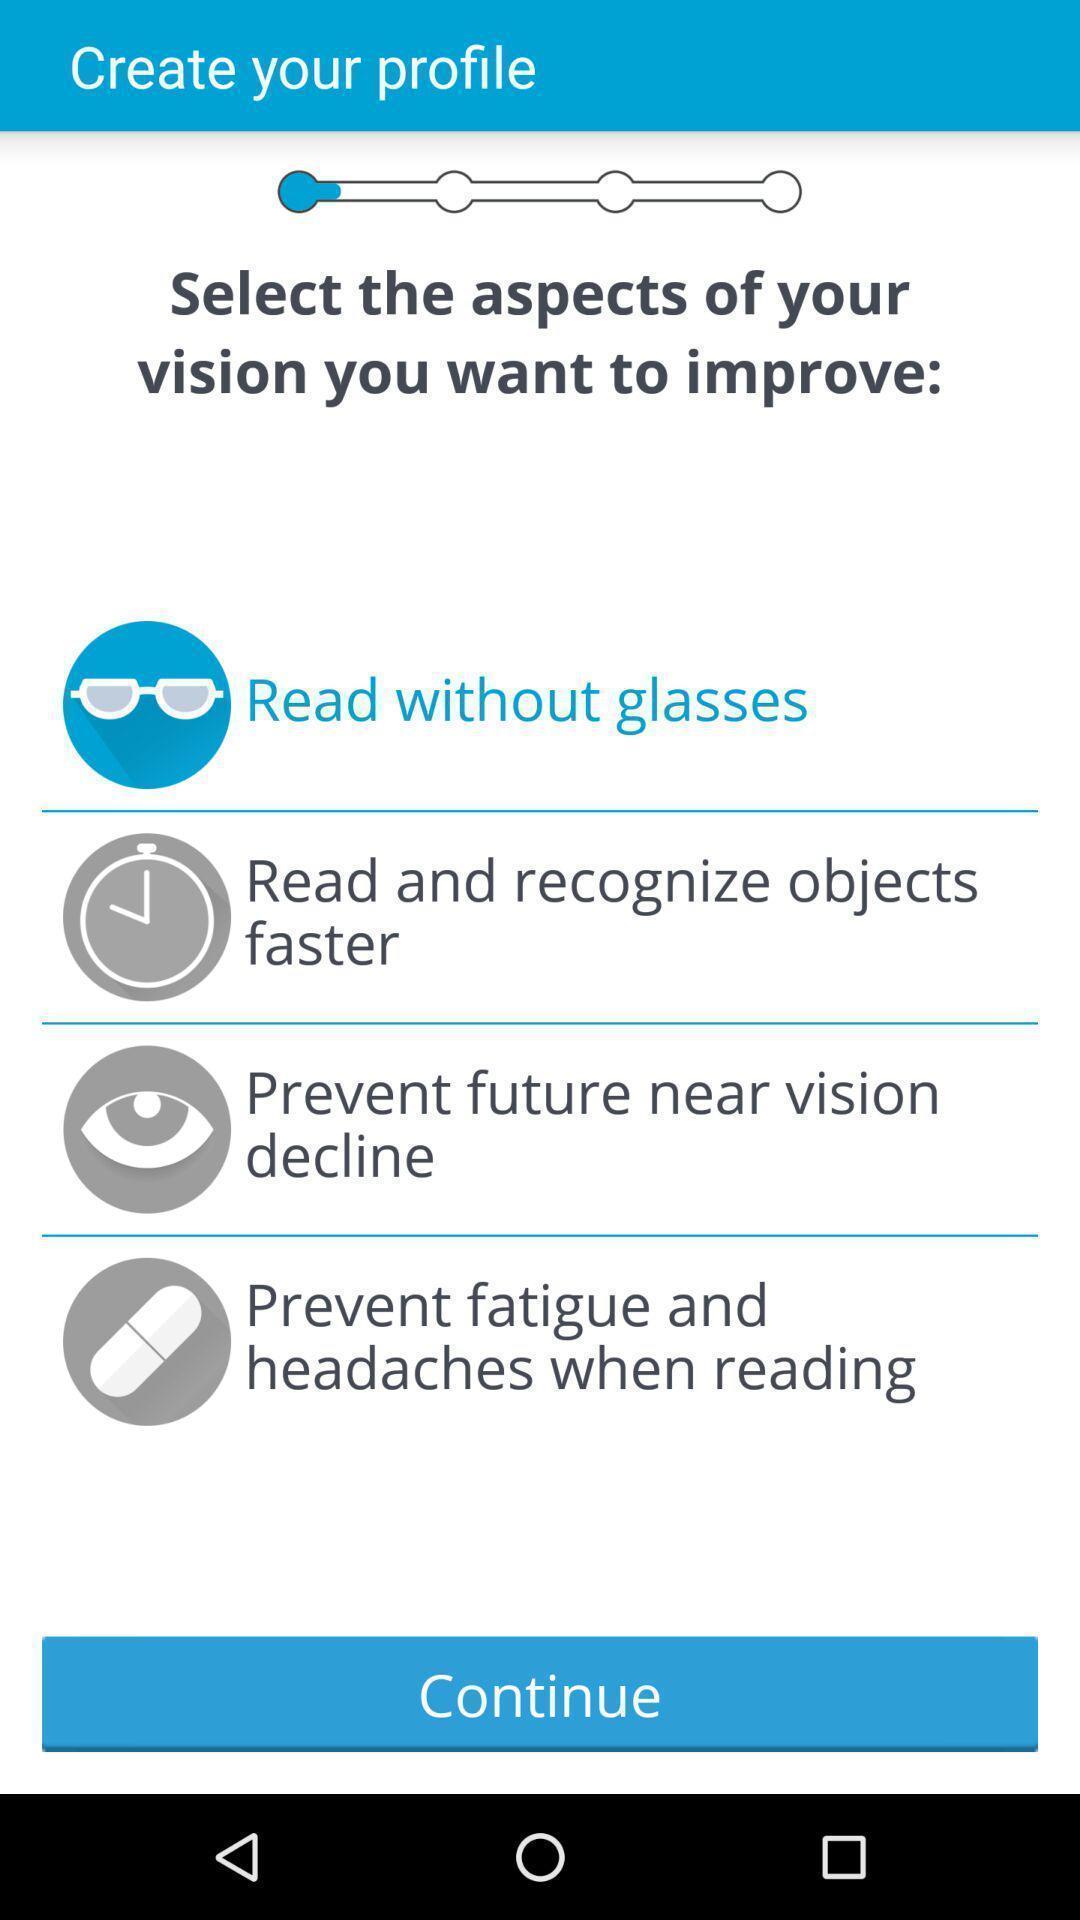Summarize the information in this screenshot. Page to create profile by selecting vision option to improve. 